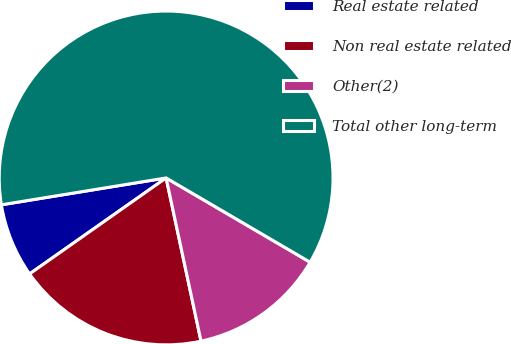Convert chart to OTSL. <chart><loc_0><loc_0><loc_500><loc_500><pie_chart><fcel>Real estate related<fcel>Non real estate related<fcel>Other(2)<fcel>Total other long-term<nl><fcel>7.18%<fcel>18.6%<fcel>13.22%<fcel>61.0%<nl></chart> 